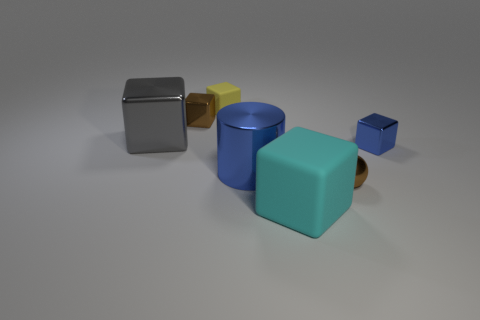Is the large thing left of the large blue shiny object made of the same material as the big cube in front of the big cylinder?
Ensure brevity in your answer.  No. What size is the shiny object that is right of the cyan rubber thing and in front of the small blue cube?
Offer a terse response. Small. What material is the brown cube that is the same size as the sphere?
Give a very brief answer. Metal. There is a brown object that is to the right of the blue shiny object that is on the left side of the cyan rubber object; what number of big gray shiny things are to the left of it?
Give a very brief answer. 1. Do the tiny metallic object to the left of the yellow matte thing and the small metallic thing in front of the large blue metal cylinder have the same color?
Offer a very short reply. Yes. There is a cube that is both right of the large blue cylinder and behind the large matte object; what color is it?
Keep it short and to the point. Blue. How many blue things are the same size as the blue metal cube?
Provide a succinct answer. 0. There is a small brown object that is in front of the small metallic object that is behind the large shiny block; what is its shape?
Offer a very short reply. Sphere. The large metal object to the left of the matte thing behind the metallic cylinder that is on the right side of the large metallic cube is what shape?
Your answer should be compact. Cube. How many other brown objects are the same shape as the tiny rubber object?
Ensure brevity in your answer.  1. 